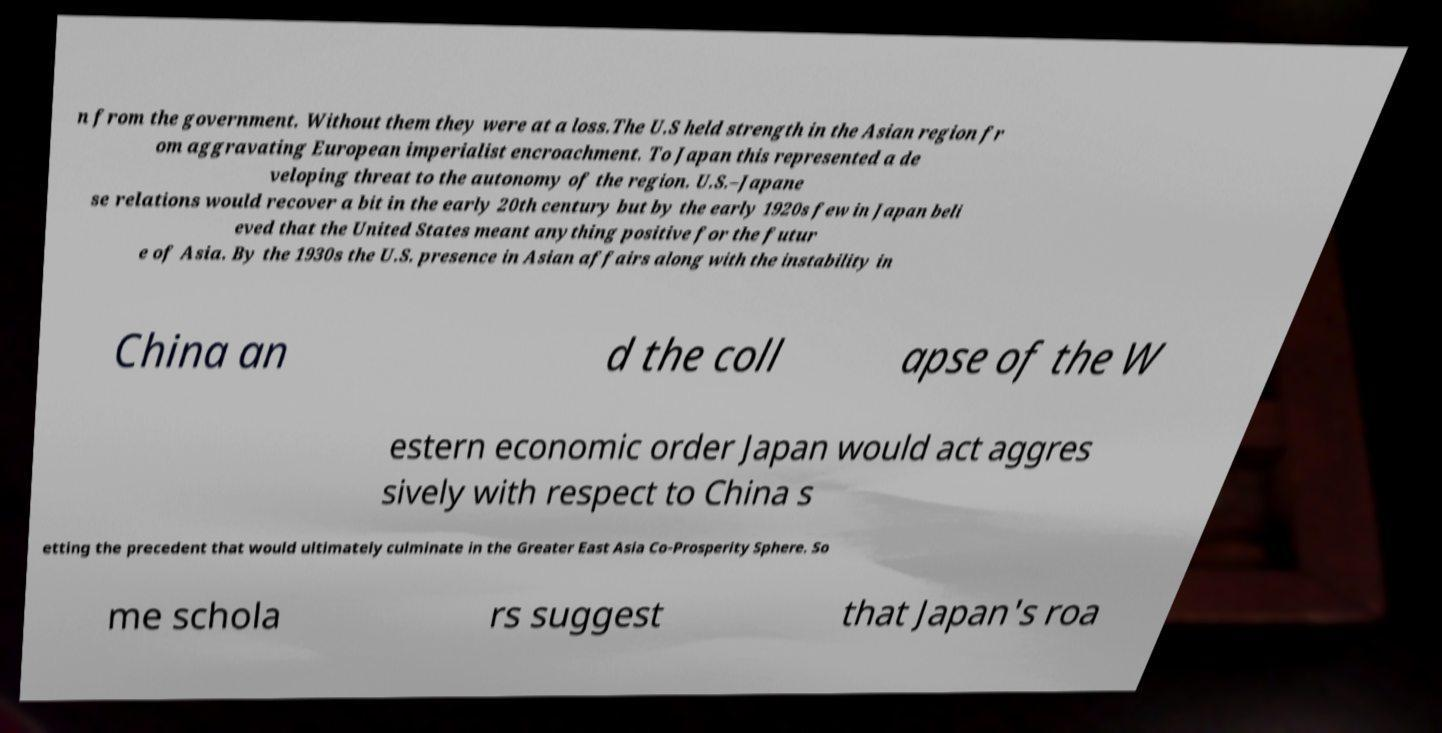Please read and relay the text visible in this image. What does it say? n from the government. Without them they were at a loss.The U.S held strength in the Asian region fr om aggravating European imperialist encroachment. To Japan this represented a de veloping threat to the autonomy of the region. U.S.–Japane se relations would recover a bit in the early 20th century but by the early 1920s few in Japan beli eved that the United States meant anything positive for the futur e of Asia. By the 1930s the U.S. presence in Asian affairs along with the instability in China an d the coll apse of the W estern economic order Japan would act aggres sively with respect to China s etting the precedent that would ultimately culminate in the Greater East Asia Co-Prosperity Sphere. So me schola rs suggest that Japan's roa 